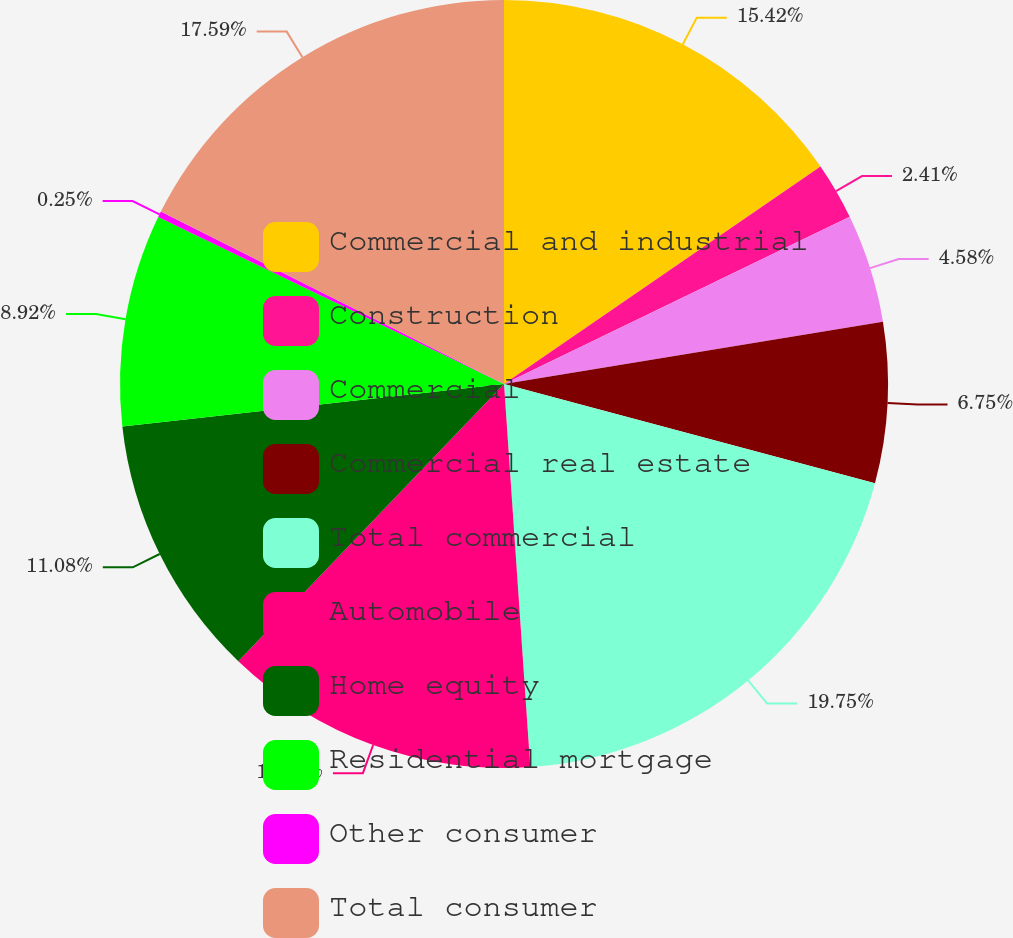<chart> <loc_0><loc_0><loc_500><loc_500><pie_chart><fcel>Commercial and industrial<fcel>Construction<fcel>Commercial<fcel>Commercial real estate<fcel>Total commercial<fcel>Automobile<fcel>Home equity<fcel>Residential mortgage<fcel>Other consumer<fcel>Total consumer<nl><fcel>15.42%<fcel>2.41%<fcel>4.58%<fcel>6.75%<fcel>19.75%<fcel>13.25%<fcel>11.08%<fcel>8.92%<fcel>0.25%<fcel>17.59%<nl></chart> 